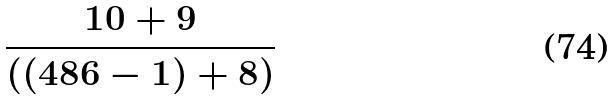Convert formula to latex. <formula><loc_0><loc_0><loc_500><loc_500>\frac { 1 0 + 9 } { ( ( 4 8 6 - 1 ) + 8 ) }</formula> 